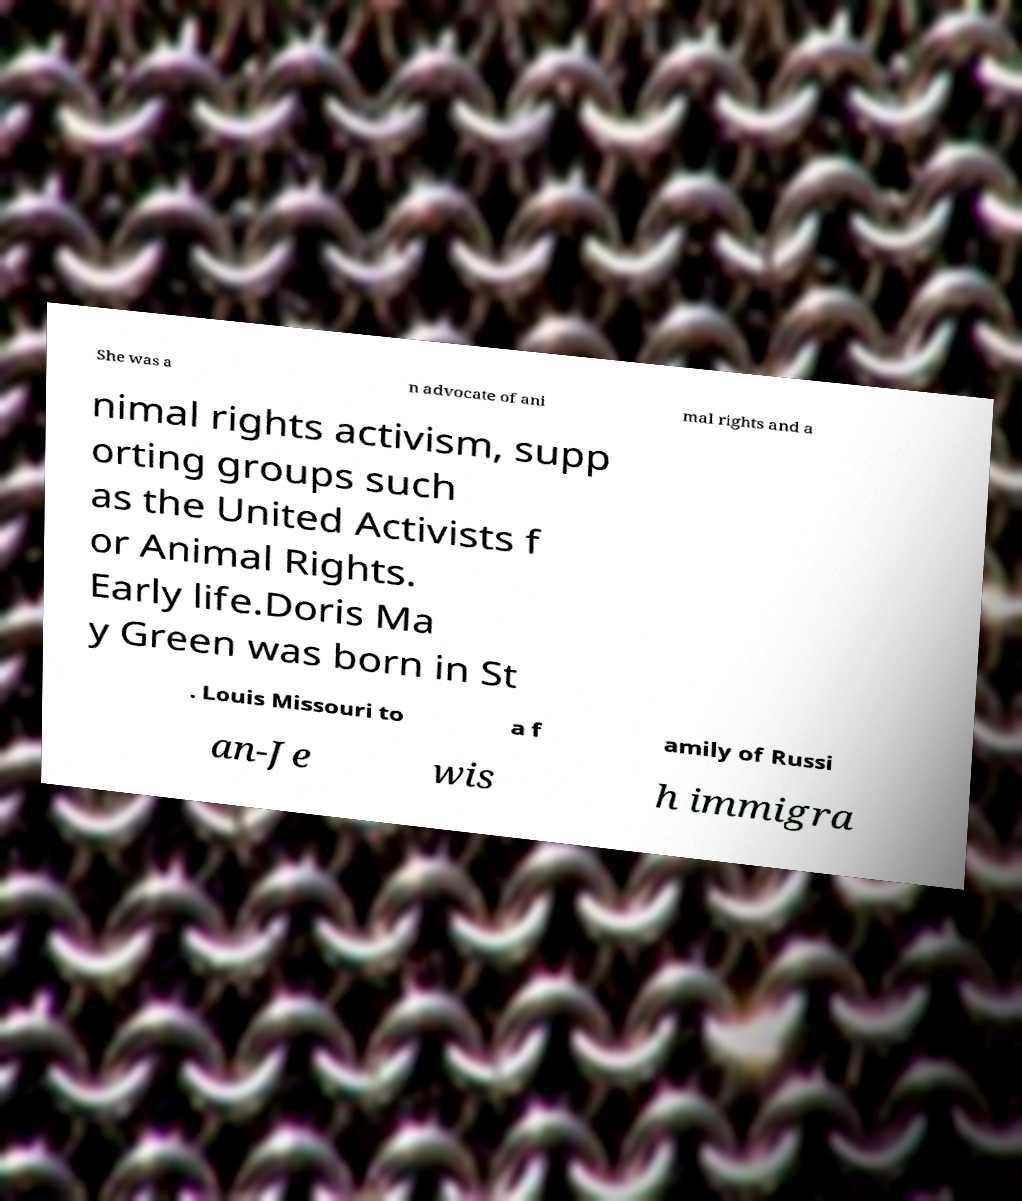Can you accurately transcribe the text from the provided image for me? She was a n advocate of ani mal rights and a nimal rights activism, supp orting groups such as the United Activists f or Animal Rights. Early life.Doris Ma y Green was born in St . Louis Missouri to a f amily of Russi an-Je wis h immigra 